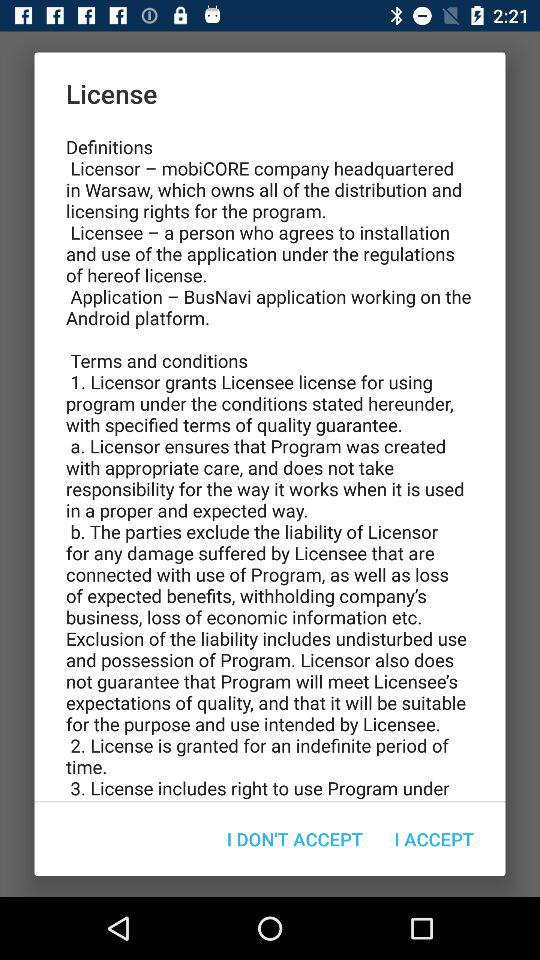What application is working on the Android platform? The application working on the Android platform is "BusNavi". 